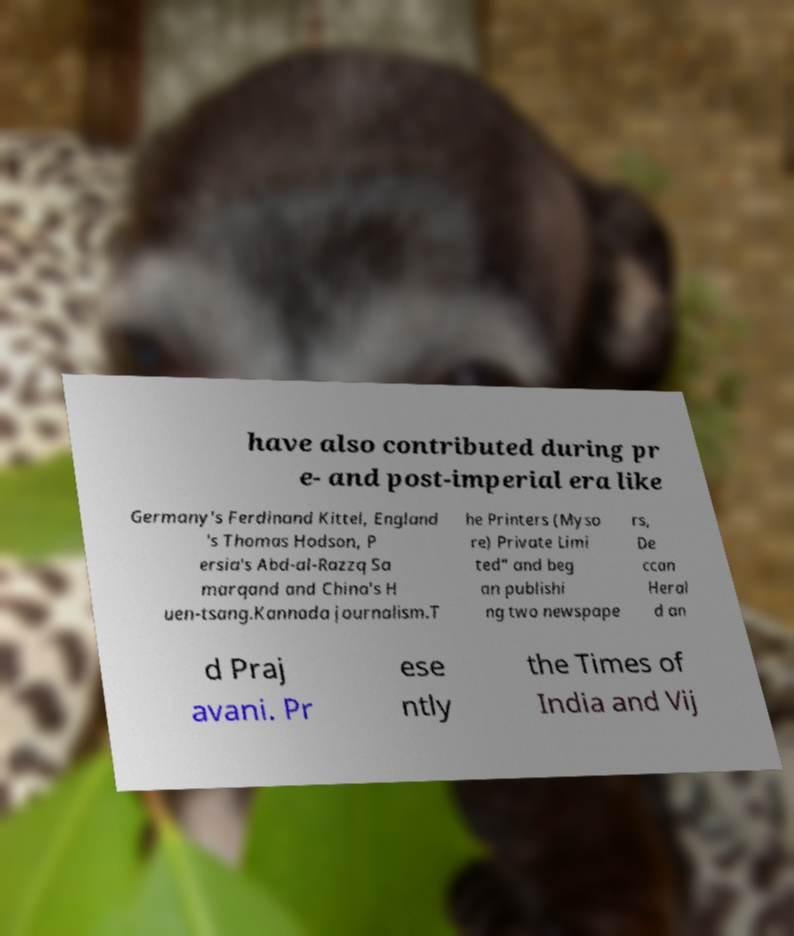I need the written content from this picture converted into text. Can you do that? have also contributed during pr e- and post-imperial era like Germany's Ferdinand Kittel, England 's Thomas Hodson, P ersia's Abd-al-Razzq Sa marqand and China's H uen-tsang.Kannada journalism.T he Printers (Myso re) Private Limi ted" and beg an publishi ng two newspape rs, De ccan Heral d an d Praj avani. Pr ese ntly the Times of India and Vij 